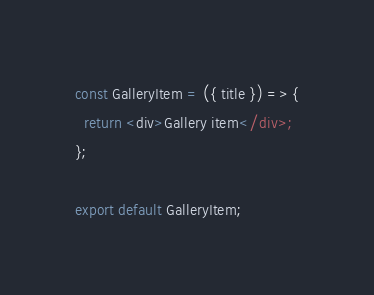Convert code to text. <code><loc_0><loc_0><loc_500><loc_500><_JavaScript_>const GalleryItem = ({ title }) => {
  return <div>Gallery item</div>;
};

export default GalleryItem;
</code> 